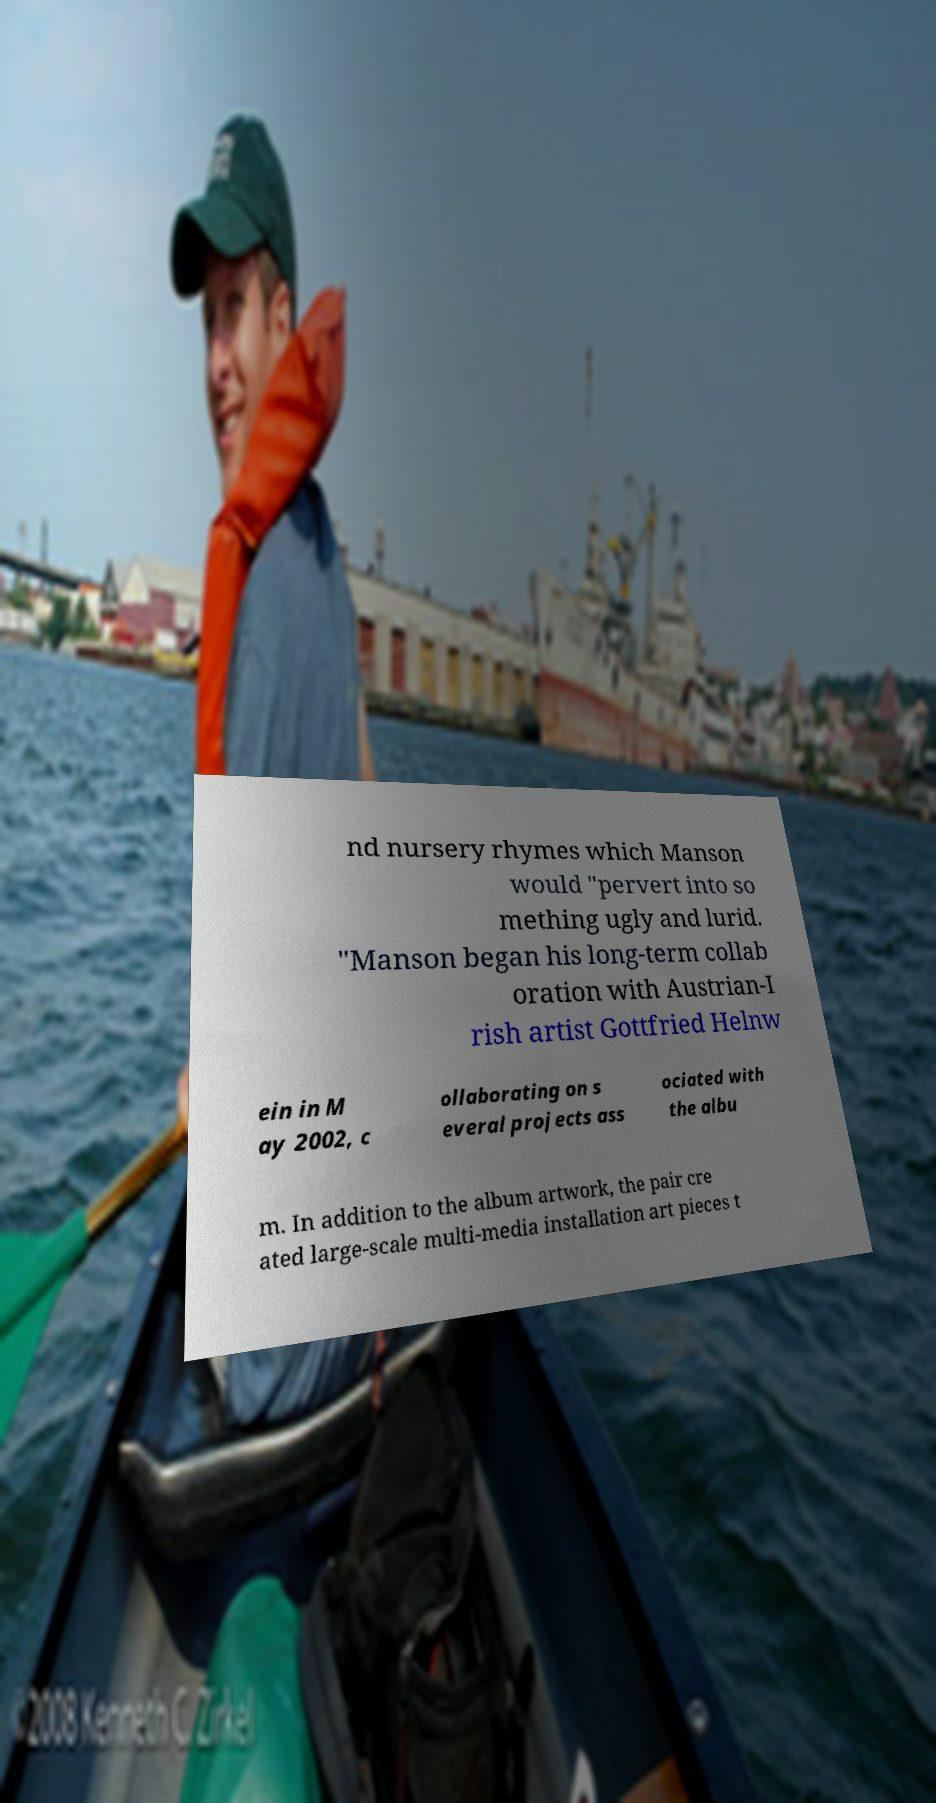Please identify and transcribe the text found in this image. nd nursery rhymes which Manson would "pervert into so mething ugly and lurid. "Manson began his long-term collab oration with Austrian-I rish artist Gottfried Helnw ein in M ay 2002, c ollaborating on s everal projects ass ociated with the albu m. In addition to the album artwork, the pair cre ated large-scale multi-media installation art pieces t 